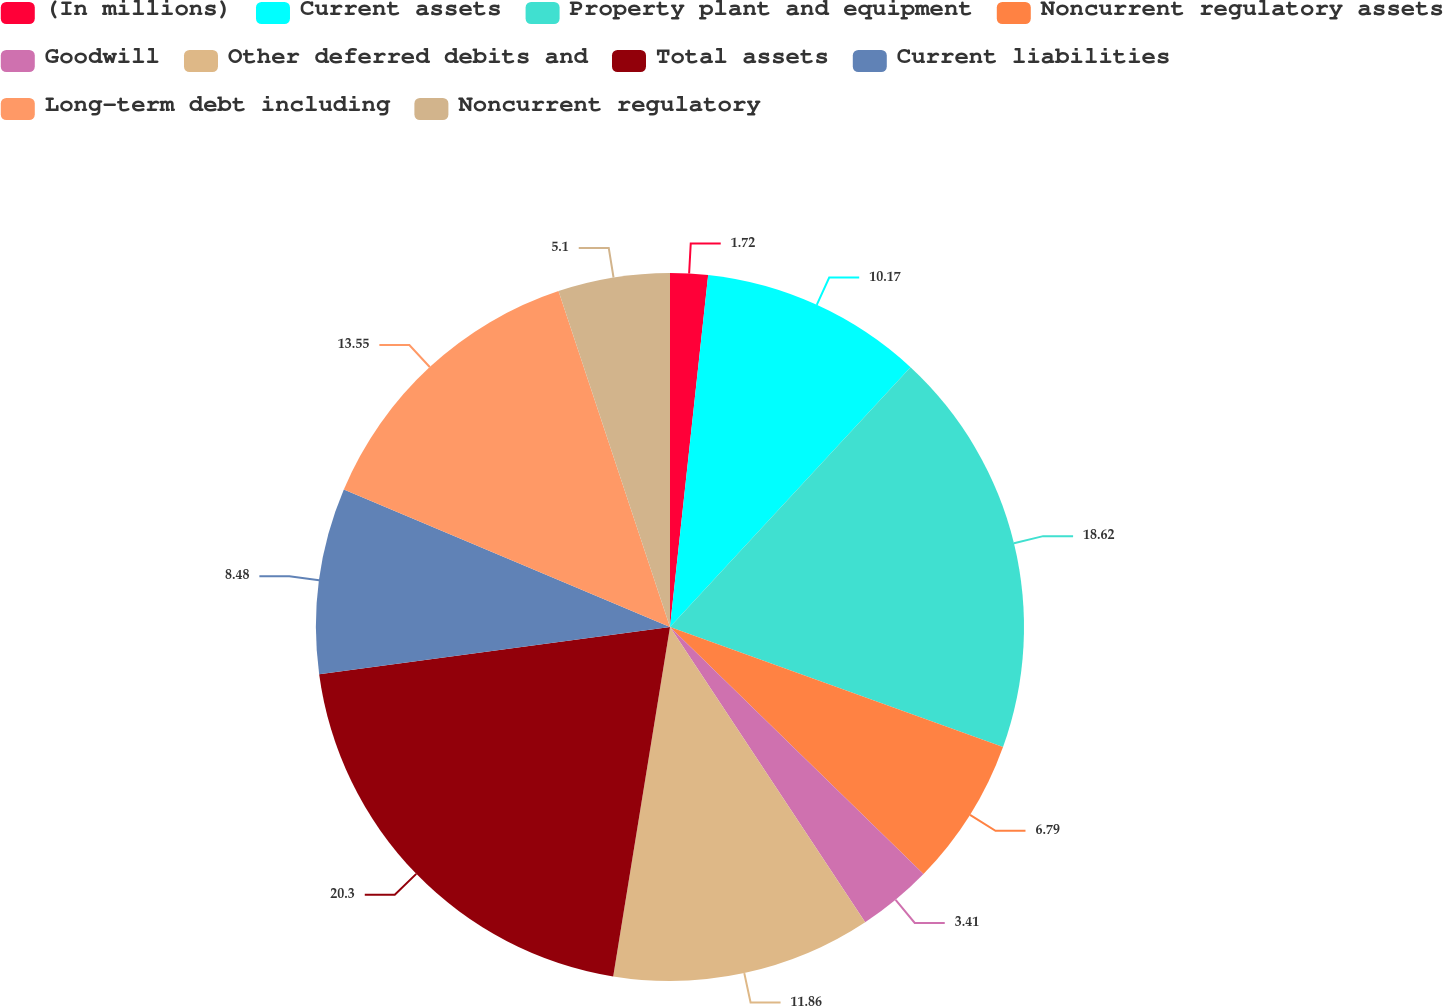Convert chart. <chart><loc_0><loc_0><loc_500><loc_500><pie_chart><fcel>(In millions)<fcel>Current assets<fcel>Property plant and equipment<fcel>Noncurrent regulatory assets<fcel>Goodwill<fcel>Other deferred debits and<fcel>Total assets<fcel>Current liabilities<fcel>Long-term debt including<fcel>Noncurrent regulatory<nl><fcel>1.72%<fcel>10.17%<fcel>18.62%<fcel>6.79%<fcel>3.41%<fcel>11.86%<fcel>20.31%<fcel>8.48%<fcel>13.55%<fcel>5.1%<nl></chart> 